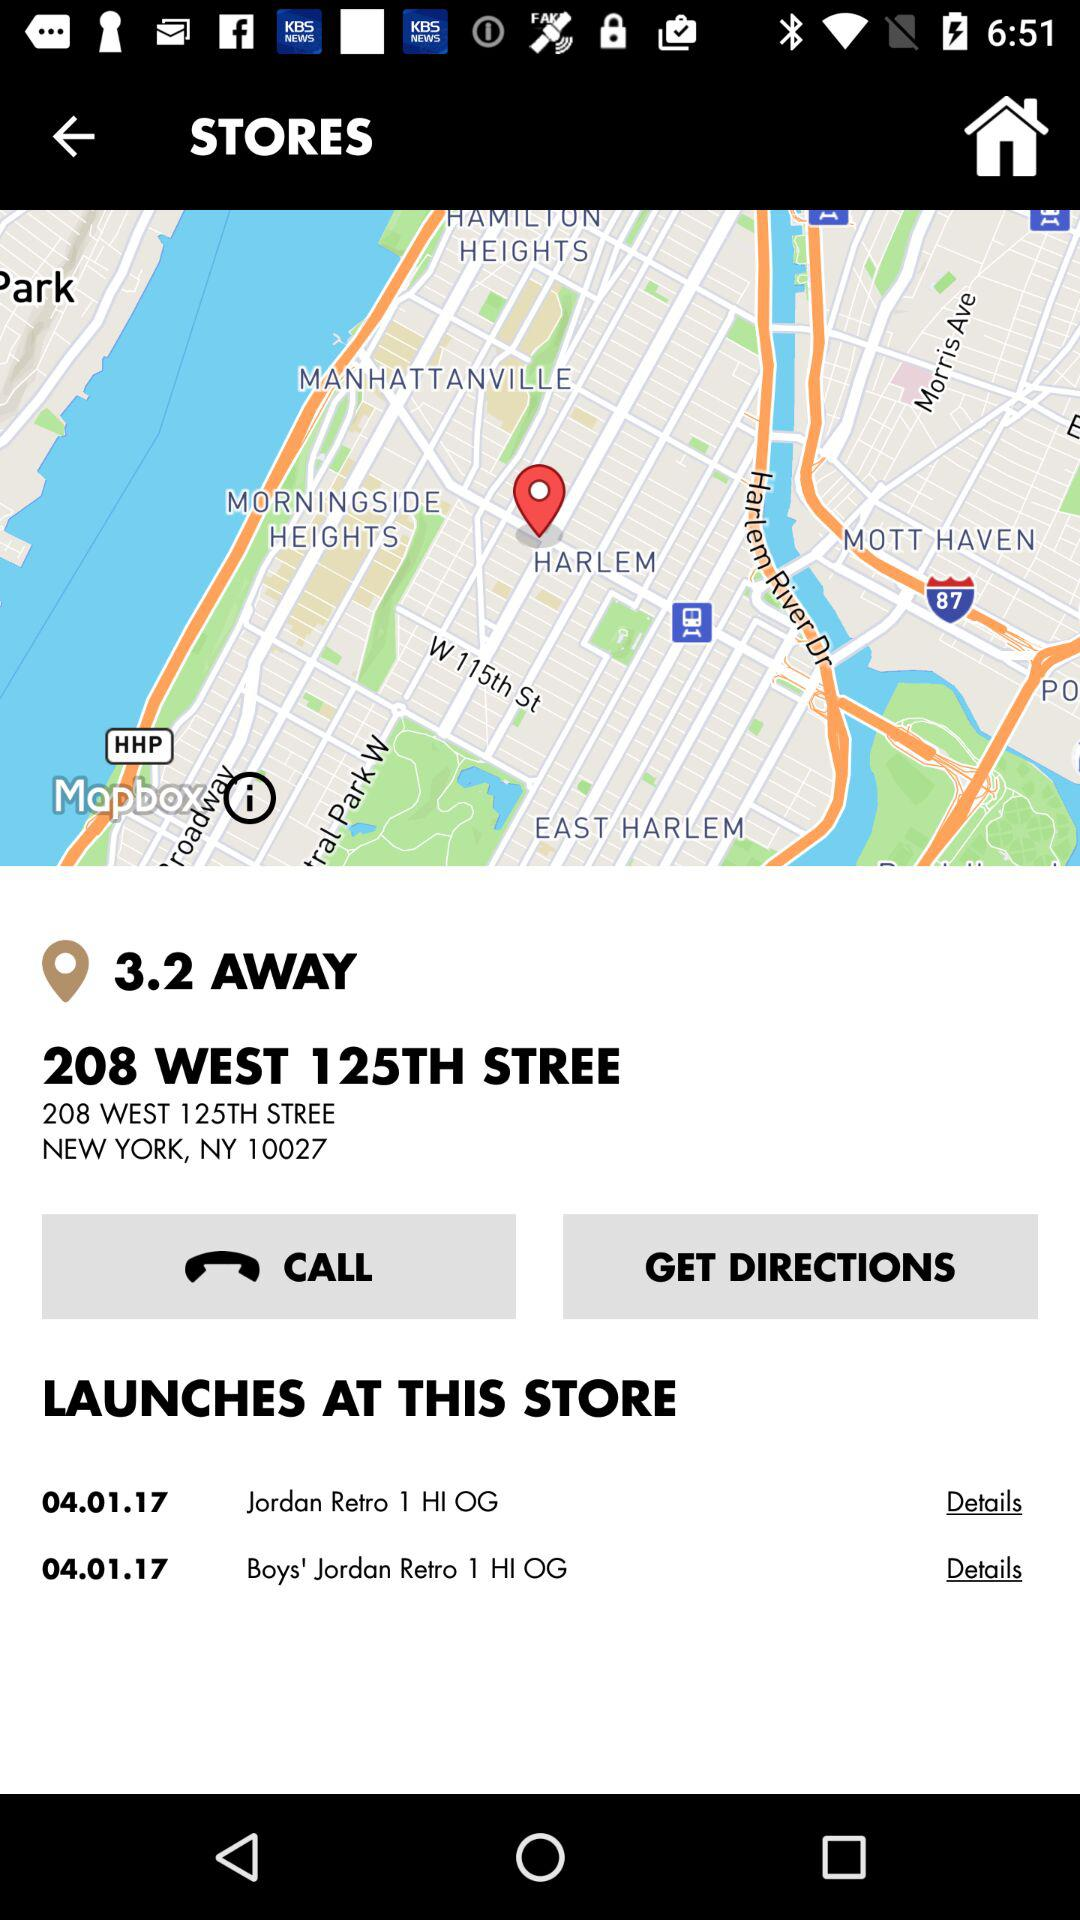What is the zip code of 208 West 125th Street, New York? The zip code of 208 West 125th Street, New York is 10027. 